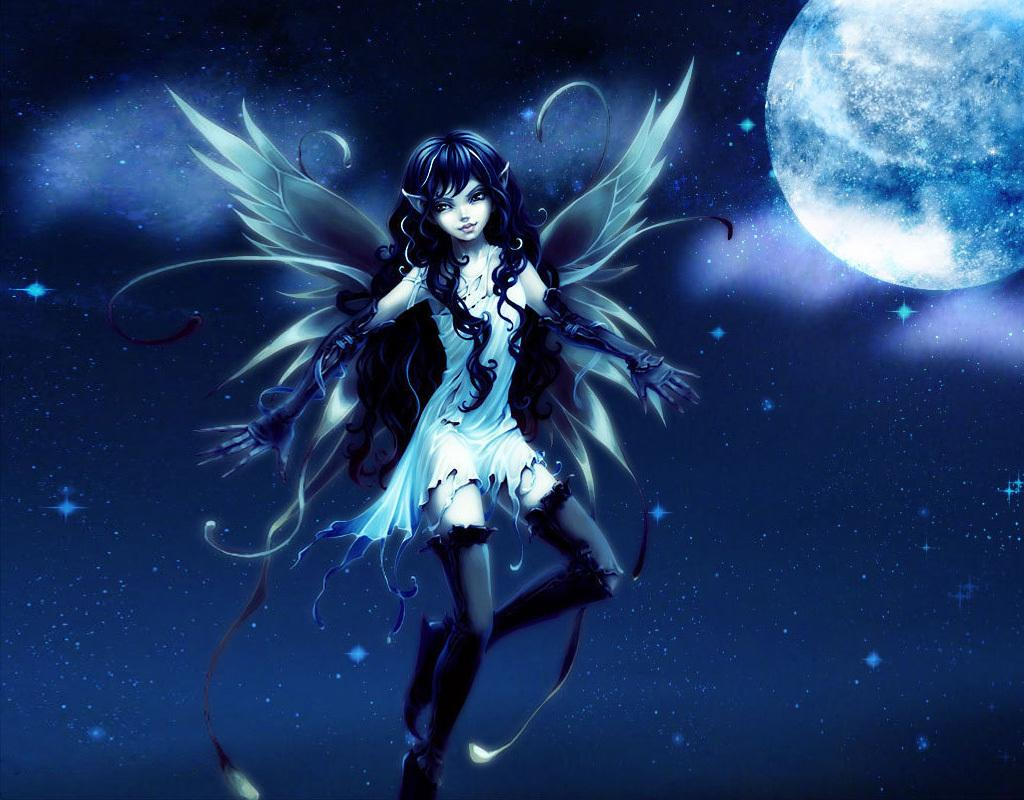What is the woman in the image doing? The woman with wings in the image is flying in the air. What can be seen in the sky in the image? There is a moon and stars visible in the sky. What type of tail does the woman have in the image? The woman in the image does not have a tail; she has wings. What design is featured on the woman's clothing in the image? The provided facts do not mention any specific design on the woman's clothing. 